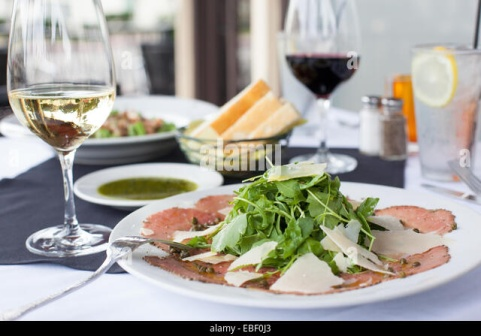What other dishes do you think might be served at this table? In this elegant dining setup, one could imagine a variety of dishes that might accompany the carpaccio. Perhaps a seasonal salad topped with heirloom tomatoes, fresh mozzarella, and a drizzle of balsharegpt4v/samic glaze. For the main course, a perfectly seared fillet of fish atop a bed of truffle risotto could be a delightful choice. On the side, a selection of artisanal cheeses and charcuterie might be presented, along with an assortment of olives, nuts, and fresh fruits, offering a blend of flavors and textures to be enjoyed with the wines. Can you describe a dessert that would complete this meal? To culminate this exquisite meal, a delicate lemon panna cotta could be served, its creamy texture balanced by a tart lemon flavor, and topped with a fresh berry compote. Alternatively, an artisanal chocolate fondant with a molten center paired with a dollop of vanilla bean ice cream could provide a sweet and decadent conclusion to the dining experience. 